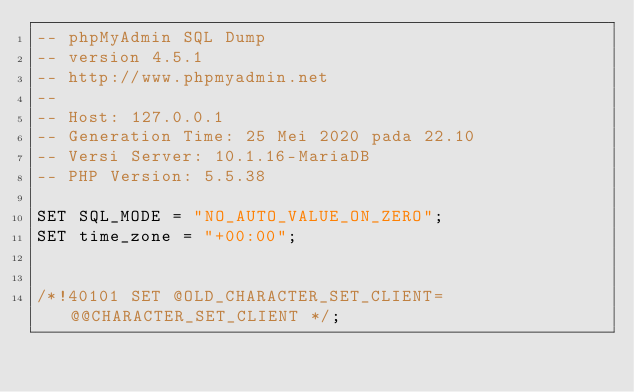<code> <loc_0><loc_0><loc_500><loc_500><_SQL_>-- phpMyAdmin SQL Dump
-- version 4.5.1
-- http://www.phpmyadmin.net
--
-- Host: 127.0.0.1
-- Generation Time: 25 Mei 2020 pada 22.10
-- Versi Server: 10.1.16-MariaDB
-- PHP Version: 5.5.38

SET SQL_MODE = "NO_AUTO_VALUE_ON_ZERO";
SET time_zone = "+00:00";


/*!40101 SET @OLD_CHARACTER_SET_CLIENT=@@CHARACTER_SET_CLIENT */;</code> 